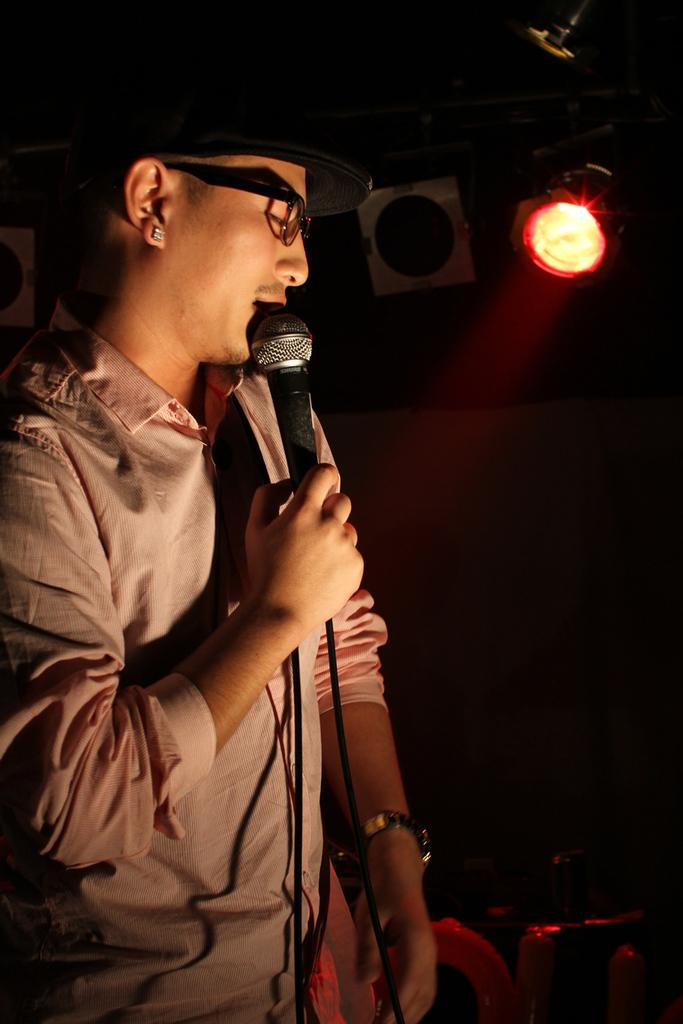What is the person on the left side of the image doing? The person is singing on a microphone. What can be seen on the right side of the image? There is a lightning arrangement on the right side of the image. What type of butter is being used to lubricate the person's toe in the image? There is no butter or toe present in the image; the person is singing on a microphone, and there is a lightning arrangement on the right side. 